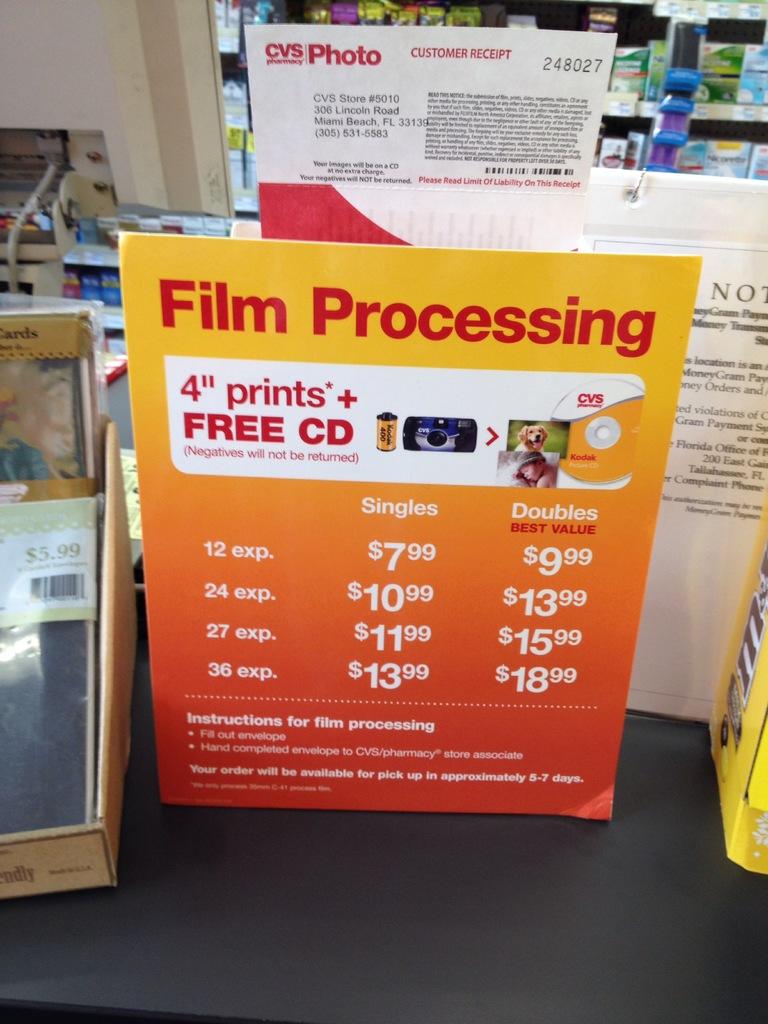What will they include for free?
Your answer should be very brief. Cd. 